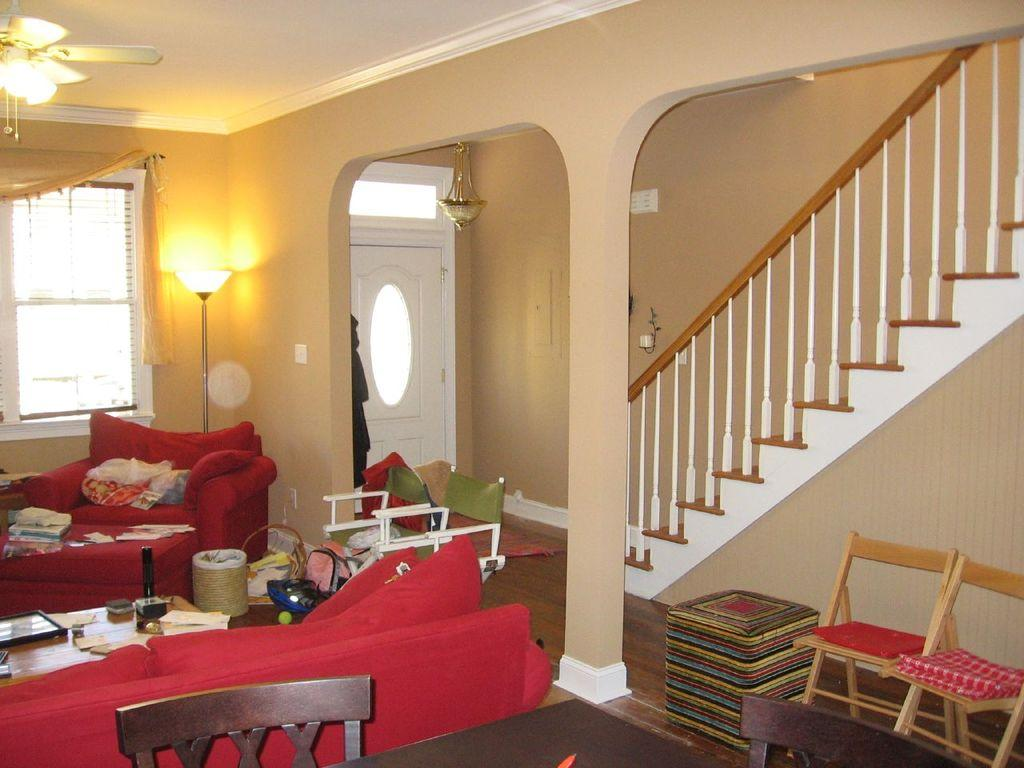What type of furniture is red in color in the room? There is a red color chair and a red color sofa in the room. What architectural feature is present in the room? There are stairs in the room. What is on the table in the room? There are papers and a photo frame on the table. What type of surface is available for placing items in the room? There is a table in the room. How many fish are swimming in the red chair in the room? There are no fish present in the room, and the red chair is a piece of furniture, not an aquarium. What type of tool is used to tighten or loosen bolts on the red sofa in the room? There is no wrench present in the room, and the red sofa is a piece of furniture, not a mechanical object. 